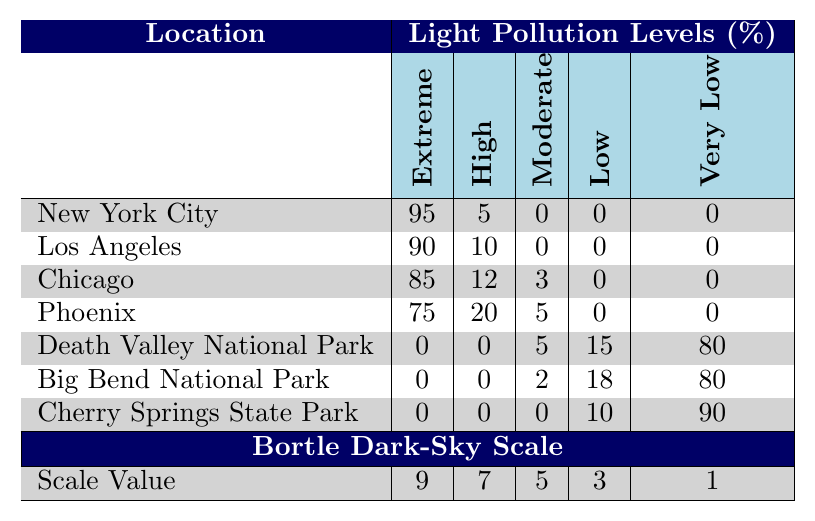What is the light pollution level in Death Valley National Park? In the table, for Death Valley National Park, the levels of light pollution are displayed: Extreme is 0, High is 0, Moderate is 5, Low is 15, and Very Low is 80. This indicates that it has a significant Very Low light pollution level.
Answer: Very Low Which city has the highest percentage of extreme light pollution? From the table, comparing the Extreme light pollution percentages, New York City has 95%, Los Angeles has 90%, Chicago has 85%, and Phoenix has 75%. New York City has the highest value.
Answer: New York City What is the total percentage of light pollution for Chicago? Summing the values for Chicago: Extreme (85) + High (12) + Moderate (3) + Low (0) + Very Low (0) equals 100%. Therefore, the total percentage light pollution level for Chicago is 100%.
Answer: 100% Is there any location with a percentage of Moderate light pollution higher than 5%? By checking the table, Chicago has a Moderate level of 3%, Phoenix has 5%, while all other locations have Moderate levels of 0%. Thus, no location has a Moderate level higher than 5%.
Answer: No Calculate the average percentage of Very Low light pollution across the locations. Summing the Very Low percentages: 0 + 0 + 0 + 0 + 80 + 80 + 90 + 1 equals 251. There are 7 locations providing data, so the average is 251 / 7, which equals approximately 35.14.
Answer: 35.14 Which two locations have the same level of Low light pollution? Checking the table, Death Valley National Park has Low light pollution of 15%, Big Bend National Park has 18%, and Cherry Springs State Park has 10%. None of the locations have the same percentage for Low light pollution.
Answer: None If all cities with High light pollution are compared, what is the difference in percentage between the city with the highest and the lowest High light pollution? Los Angeles has 10%, while all other urban locations (New York City 5%, Chicago 12%, and Phoenix 20%) have different values. The city with the highest High pollution (Phoenix at 20%) minus the lowest (New York City at 5%) gives a difference of 20 - 5 = 15%.
Answer: 15% What percentage of light pollution is classified as Very Low in Cherry Springs State Park? In the table, Cherry Springs State Park has a Very Low light pollution percentage of 90%.
Answer: 90% Does Big Bend National Park have any Extreme light pollution? By referring to the table, Big Bend National Park has an Extreme level of 0%, indicating it does not have any Extreme light pollution.
Answer: No What is the combined percentage of Extreme and High light pollution for Los Angeles? Adding the values for Los Angeles: Extreme (90) + High (10) equals 100%. This indicates the combined percentage of Extreme and High light pollution for Los Angeles is 100%.
Answer: 100% 